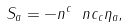Convert formula to latex. <formula><loc_0><loc_0><loc_500><loc_500>S _ { a } = - n ^ { c } \ n c _ { c } \eta _ { a } ,</formula> 